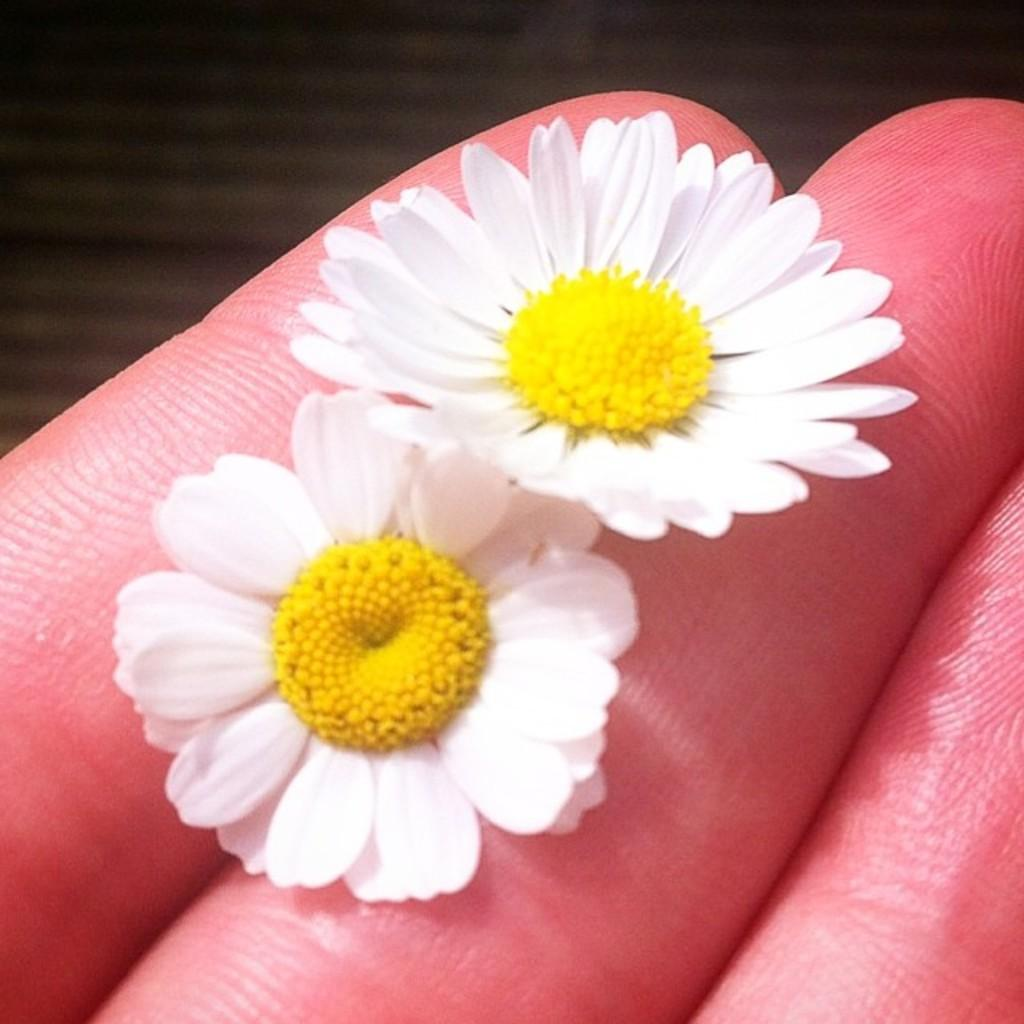What objects are on the person's fingers in the image? There are two flowers on a person's fingers in the image. Can you describe the background of the image? The background of the image is not clear. How many beetles can be seen crawling on the person's fingers in the image? There are no beetles visible on the person's fingers in the image. How many friends are present in the image? The image only shows a person with flowers on their fingers, so it is not possible to determine the number of friends present. 